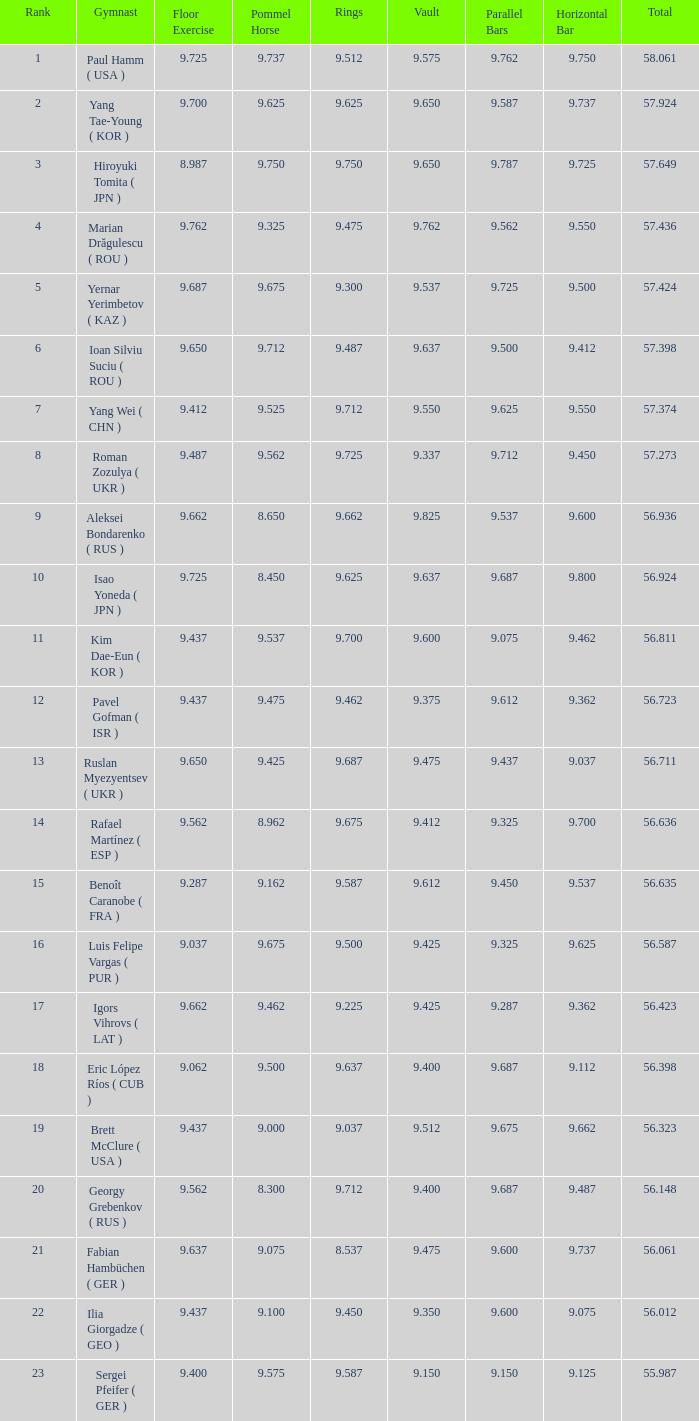What is the overall score when the score for floor routine was 56.635. 